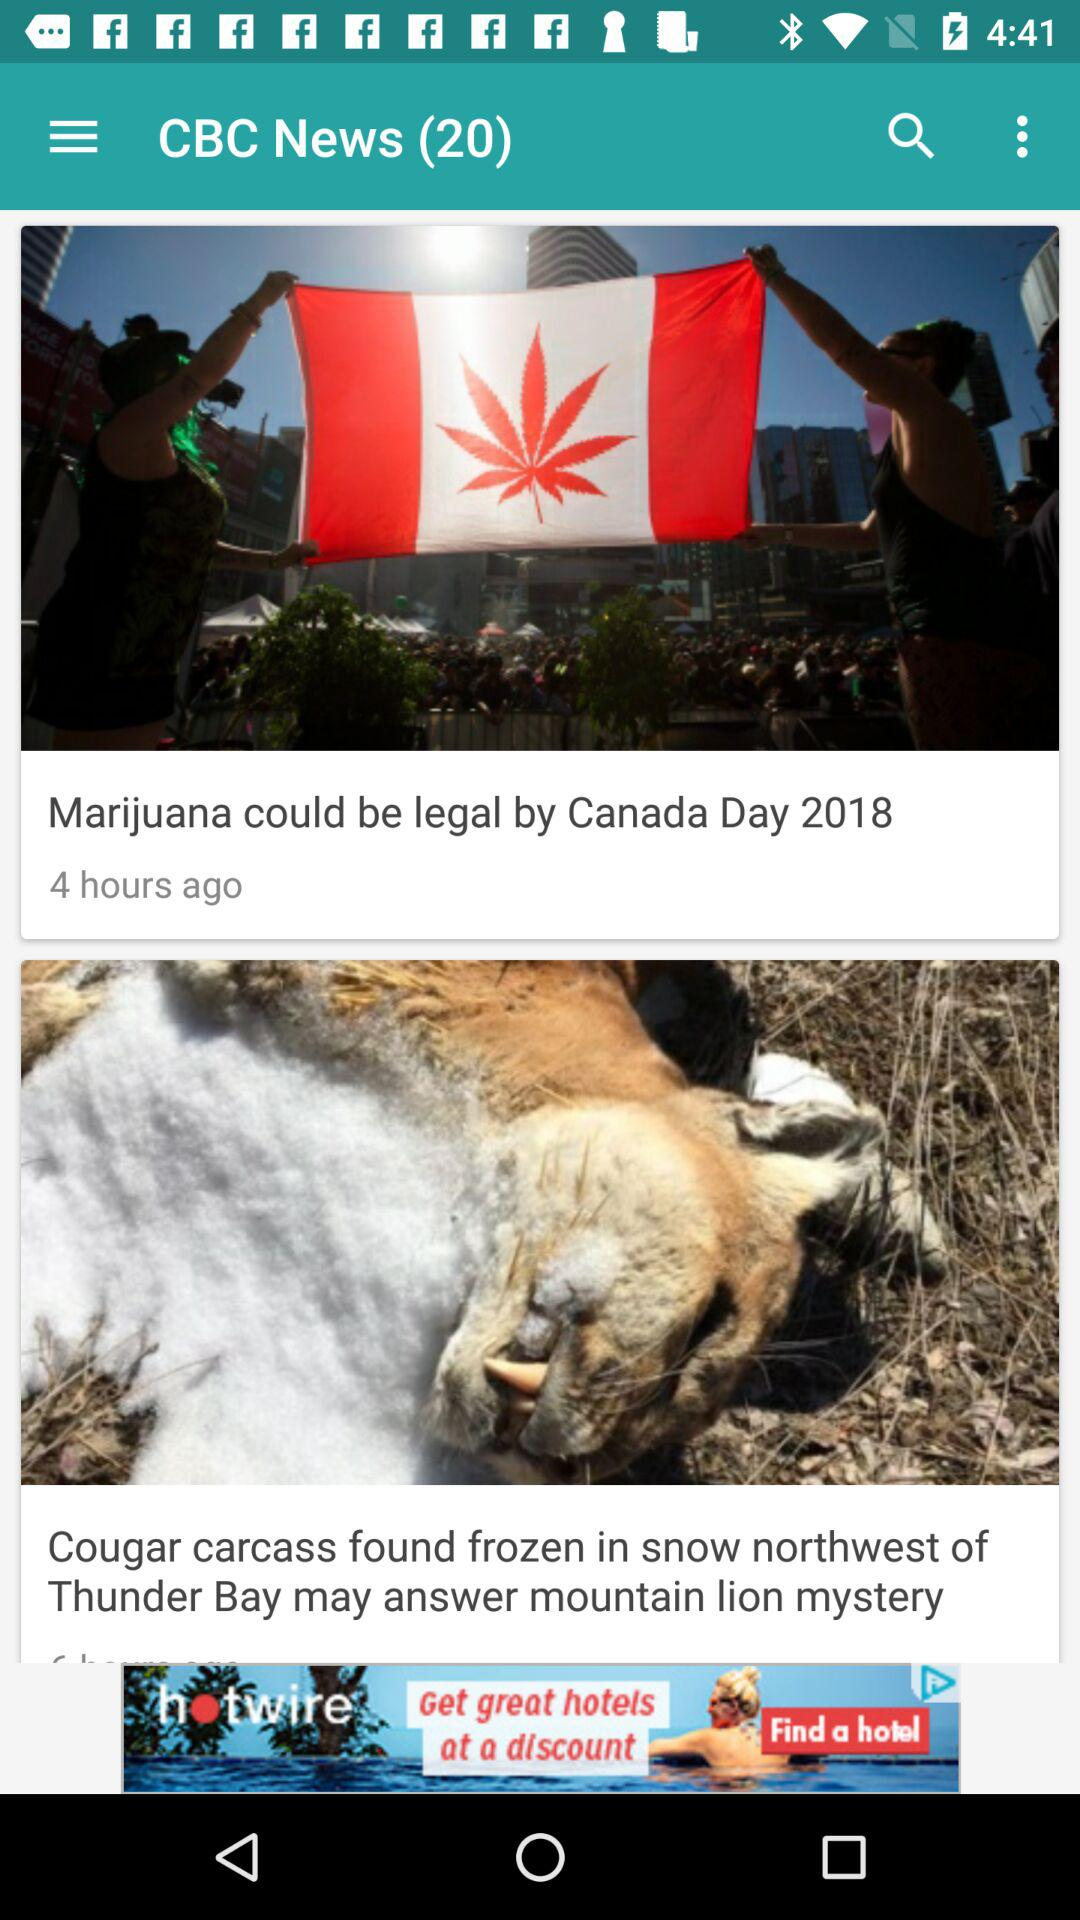What is the news channel name? The news channel name is "CBC News". 